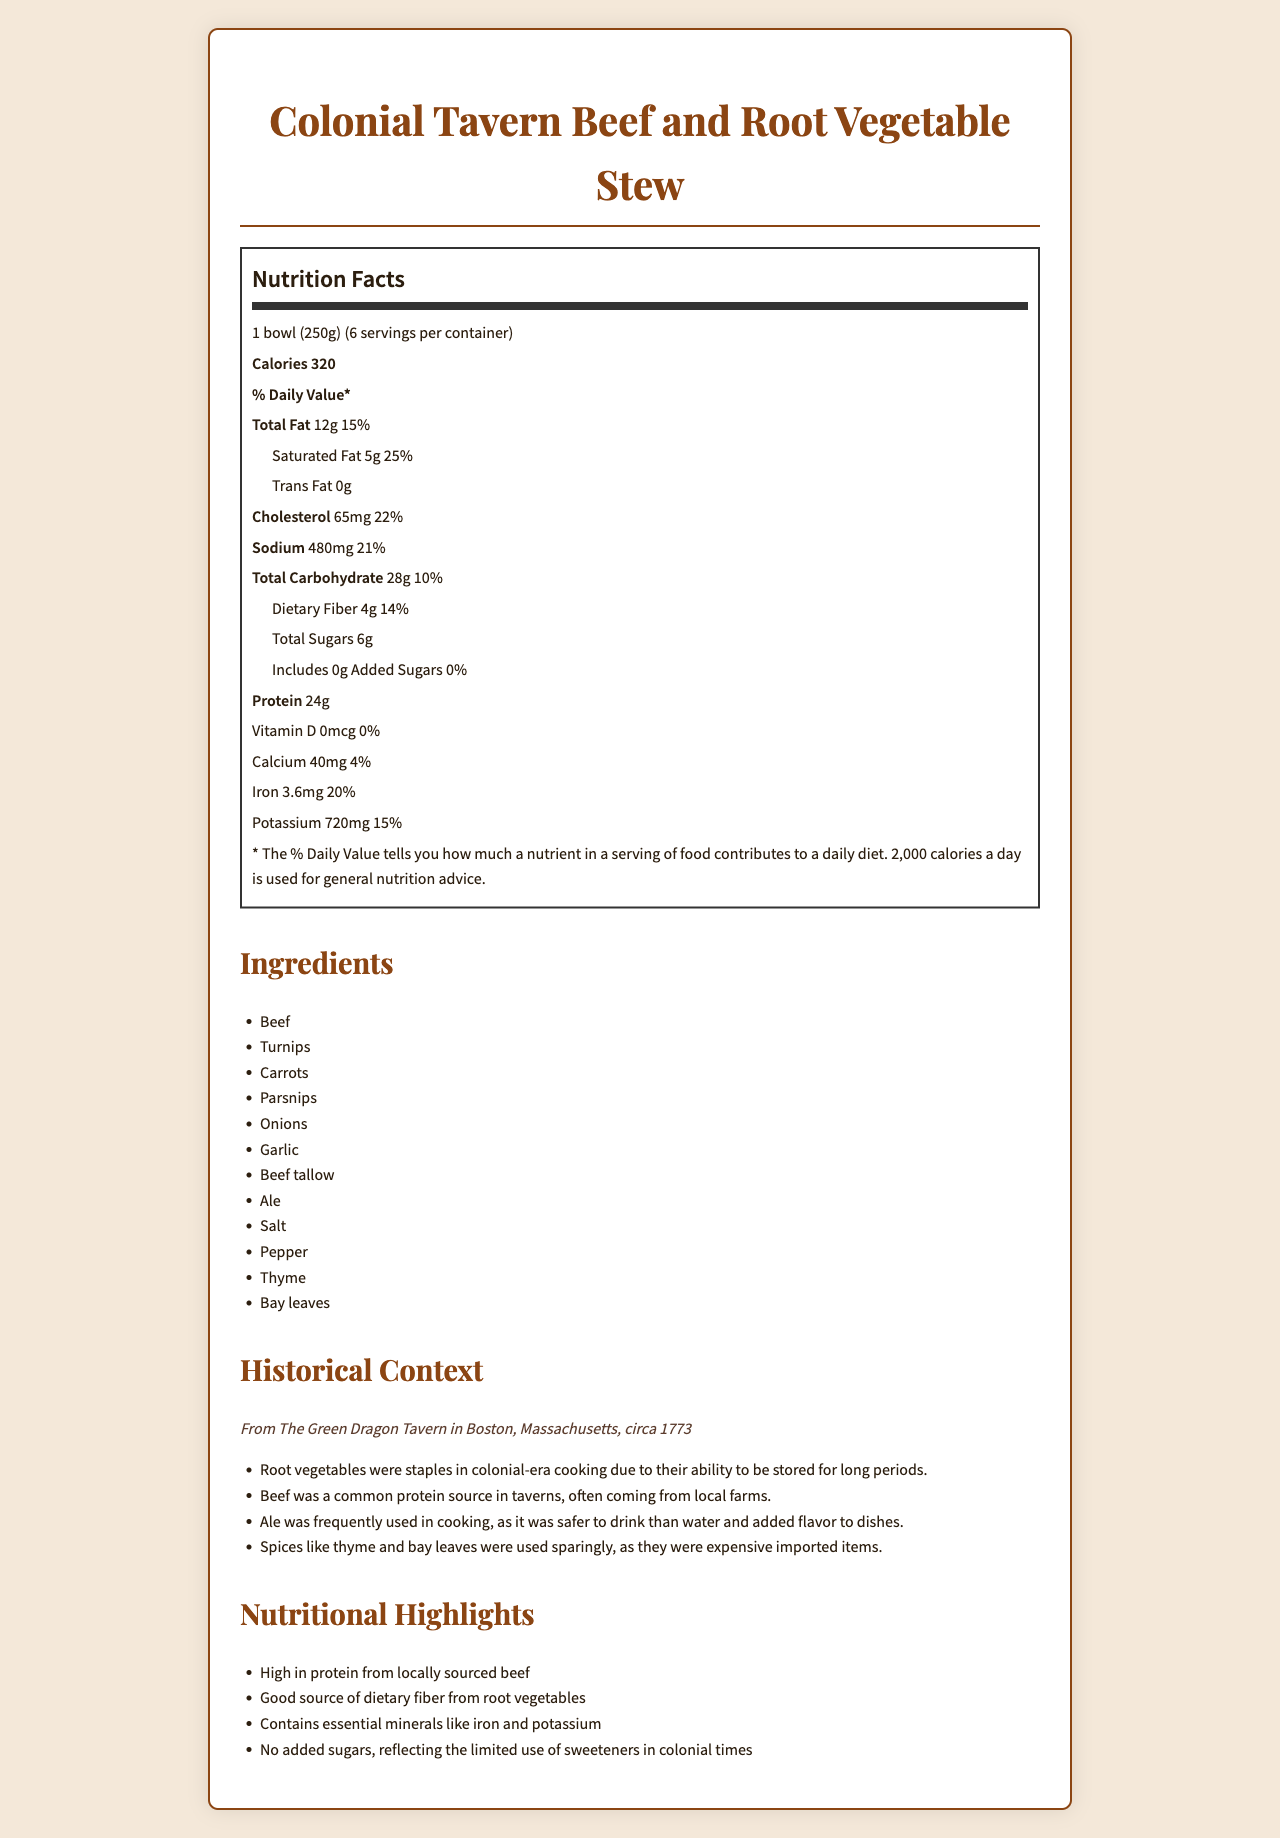what is the serving size for the Colonial Tavern Beef and Root Vegetable Stew? The serving size is mentioned under the Nutrition Facts heading as 1 bowl (250g).
Answer: 1 bowl (250g) How many servings are there per container? The document states that there are 6 servings per container.
Answer: 6 How many calories are in one serving? The calorie count per serving is listed as 320 under the Nutrition Facts.
Answer: 320 How much total fat is in one serving of the stew? The document lists the total fat content as 12g per serving.
Answer: 12g What percentage of the daily value for cholesterol does one serving contribute? The cholesterol daily value percentage is given as 22%.
Answer: 22% How much potassium is in one serving? The nutritional information shows that each serving contains 720 mg of potassium.
Answer: 720 mg Which year does the historical context of the Colonial Tavern Beef and Root Vegetable Stew refer to? A. 1770 B. 1773 C. 1800 According to the Historical Context section, the year referred to is 1773.
Answer: B What is a common characteristic of the root vegetables used in this recipe? A. Seasonal Availability B. Long Storage Life C. High Sugar Content D. High Cost The historical context mentions that root vegetables were staples because of their ability to be stored for long periods.
Answer: B Does the recipe contain any added sugars? The document states that the added sugars amount is 0g, indicating no added sugars.
Answer: No Is beef a common protein source in this colonial-era recipe? The historical context indicates that beef was a common protein source in taverns, often sourced from local farms.
Answer: Yes How is ale used in this traditional recipe? The historical context mentions that ale was frequently used in cooking for its flavor and because it was safer than water.
Answer: Ale is used for cooking and adds flavor to the stew. Summarize the main nutritional highlights of the Colonial Tavern Beef and Root Vegetable Stew. The Nutritional Highlights section details these points.
Answer: The stew is high in protein from locally sourced beef, provides dietary fiber from root vegetables, contains essential minerals like iron and potassium, and has no added sugars. Why were spices like thyme and bay leaves used sparingly in the recipe? The historical context notes that spices were used sparingly because they were costly and imported.
Answer: They were expensive imported items. What daily value percentage of calcium does one serving provide? The nutritional information indicates that one serving provides 4% of the daily value for calcium.
Answer: 4% What is the historical tavern's name where this beef and root vegetable stew was served? The Historical Context section mentions The Green Dragon Tavern.
Answer: The Green Dragon Tavern What types of questions would likely arise regarding the cooking methods or origins of the ingredients? The document provides nutritional facts, historical context, and ingredient lists but lacks detailed descriptions of cooking methods or the origins of ingredients.
Answer: Not enough information 